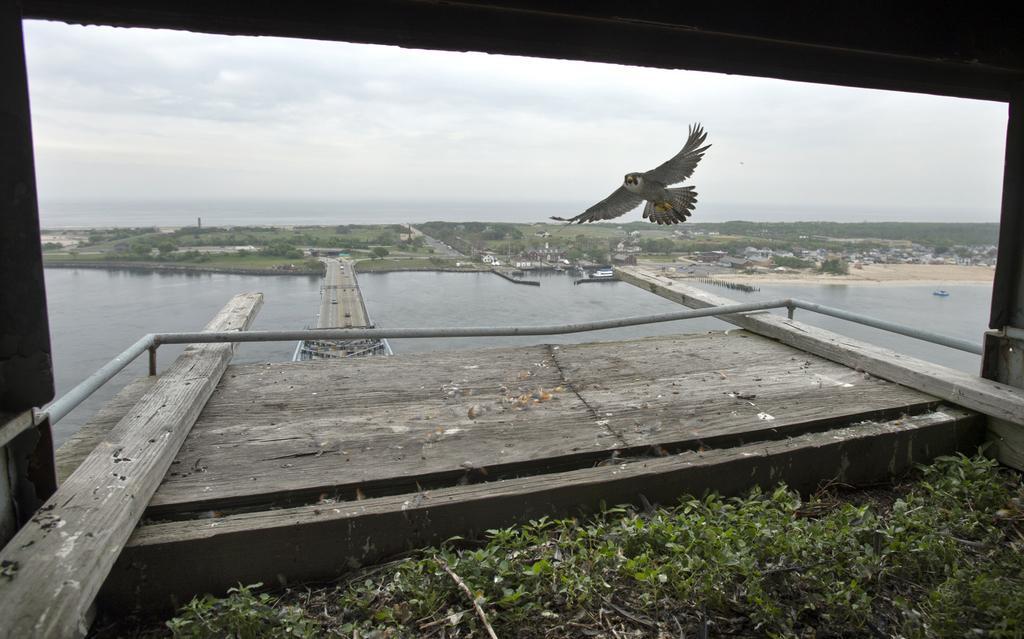Describe this image in one or two sentences. In this picture I can see a bird flying and I can see a bridge and few buildings, trees and a cloudy sky and I can see a boat on the water. 